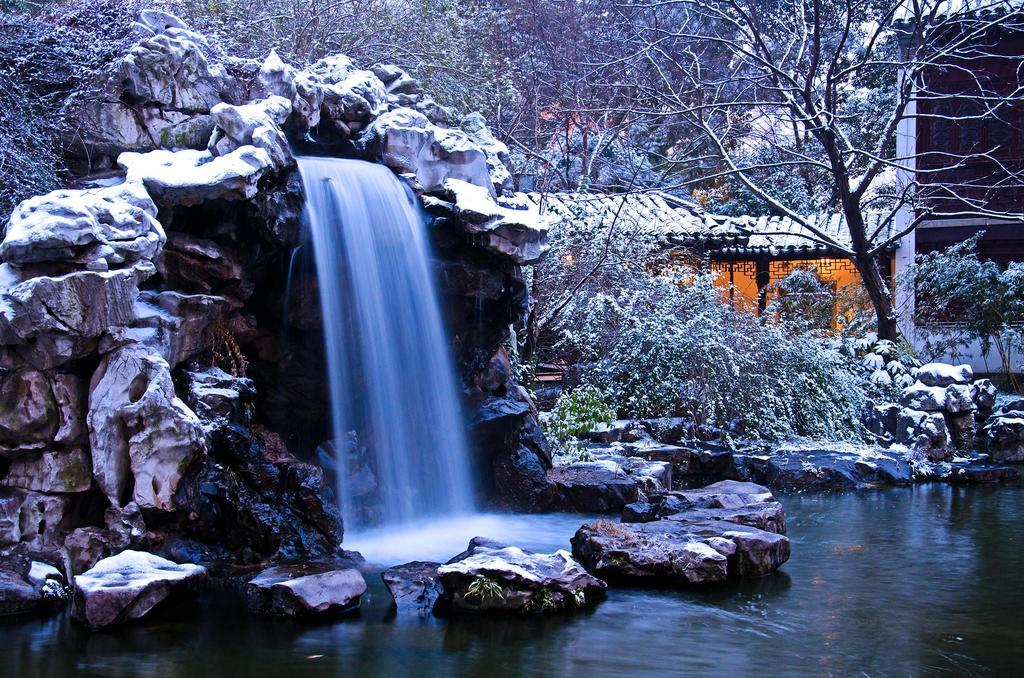What is the main feature of the image? There is water in the image. What else can be seen in the water? There are rocks in the image. Where is the waterfall located in the image? The waterfall is on the left side of the image. What can be seen in the background of the image? There are trees and buildings in the background of the image. Can you see a tooth in the water in the image? No, there is no tooth present in the water in the image. Is there a picture of a quicksand scene in the image? No, there is no quicksand or picture of quicksand in the image. 